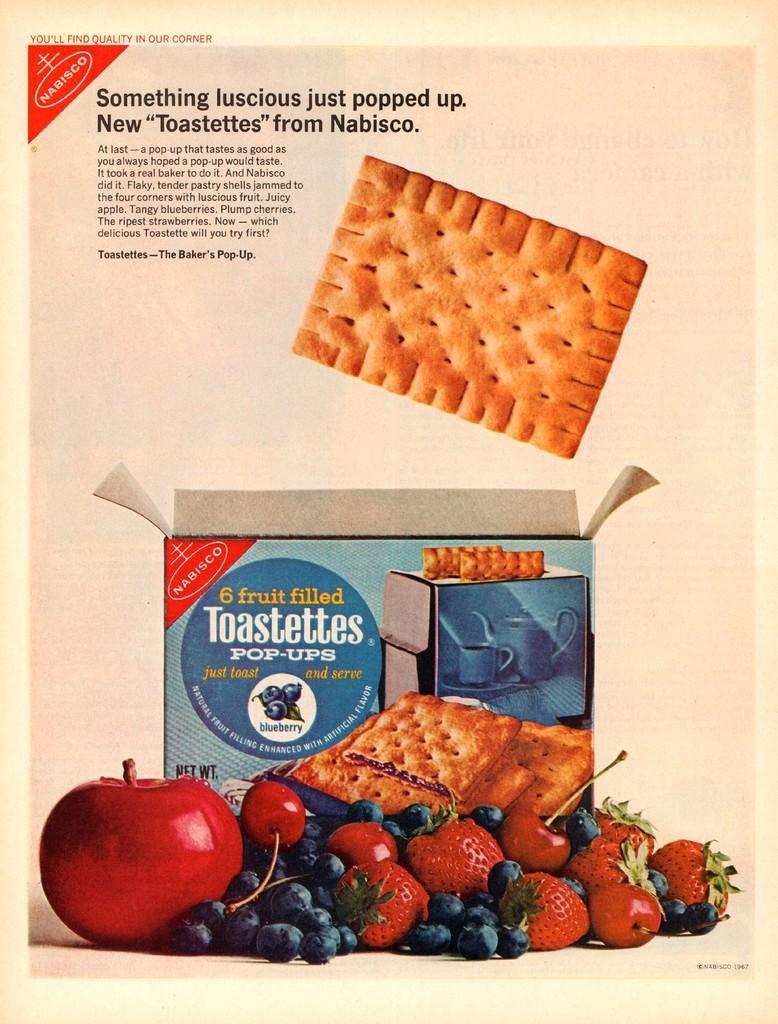Describe this image in one or two sentences. In this image there is a poster. In the top left there is text on the poster. At the bottom there are pictures of strawberries, cherries, blueberries, an apple, a box and a biscuit. There are pictures of biscuits and text on the box. 